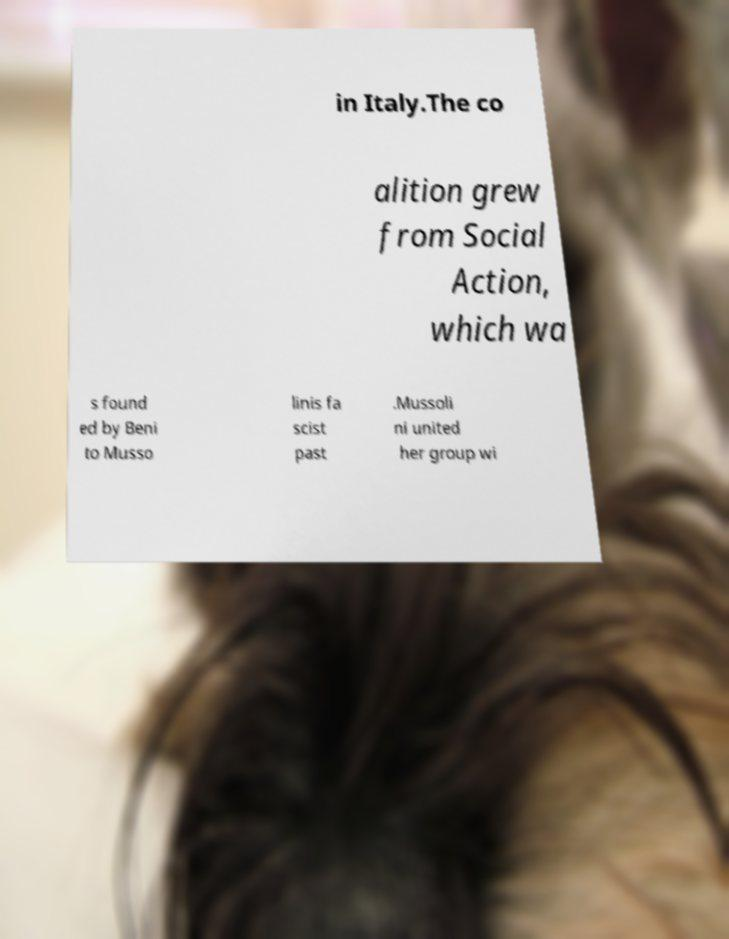For documentation purposes, I need the text within this image transcribed. Could you provide that? in Italy.The co alition grew from Social Action, which wa s found ed by Beni to Musso linis fa scist past .Mussoli ni united her group wi 